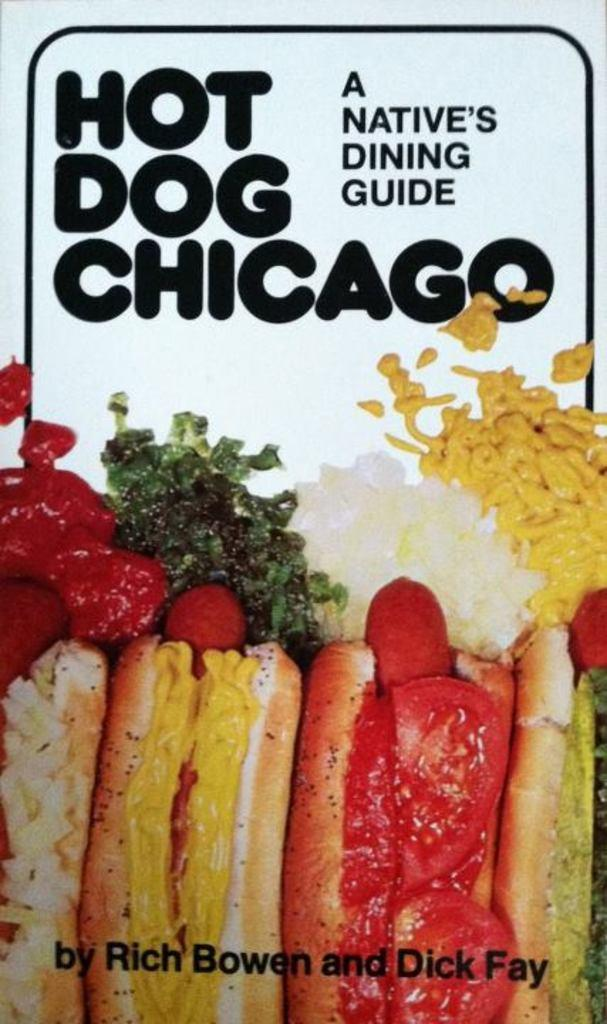What type of content is present at the bottom of the image? There is food in the image. Where is the food located in relation to the image? The food is at the bottom of the image. What other element can be found in the image? There is text in the image. Where is the text located in relation to the image? The text is at the top of the image. What type of crayon can be seen being used by the carpenter in the image? There is no crayon or carpenter present in the image. What type of humor is depicted in the image? There is no humor depicted in the image; it features food and text. 